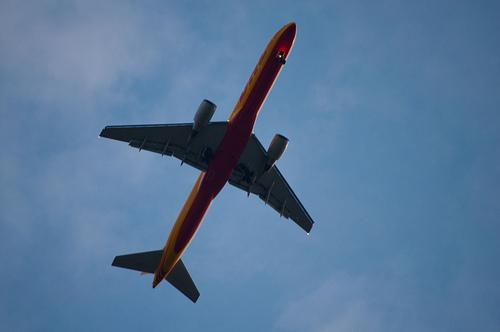Describe the appearance of the clouds in the image. The clouds in the image are white, thin, and scattered around the blue sky. What is the main activity happening in the image? A large plane with orange body is flying in a blue sky with few white clouds. What is the most dominant color in the sky? Blue is the most dominant color in the sky. Identify the primary subject in the image and the number of its wings. The primary subject is a large plane, and it has two wings on either side. List three main objects in the given image and the color of each object. Large plane with an orange body, white wings, and a red light. Determine the emotion or mood of the image. The image has a calm and serene mood, as it shows a plane flying high in the sky with white clouds around. Estimate the quality of the image based on the object's details and sharpness. The image has good quality, as the objects' details and sharpness appear accurate and clear. 